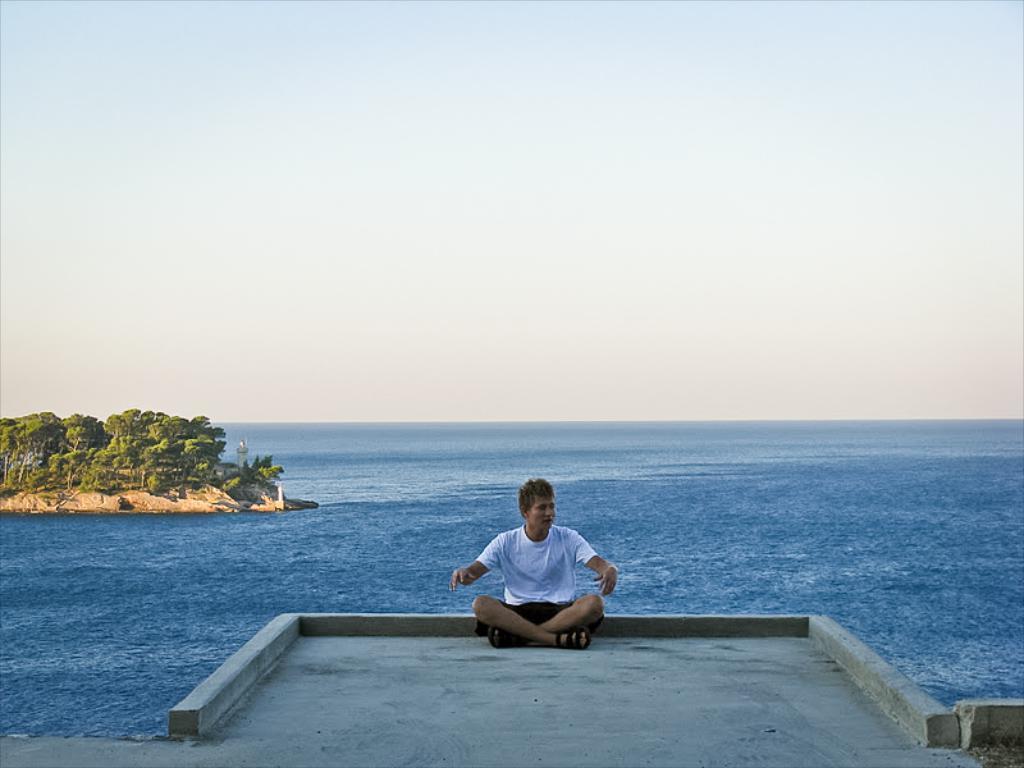Describe this image in one or two sentences. In this picture, we can see a person sitting on the floor, and we can see water, ground with trees, and the sky. 